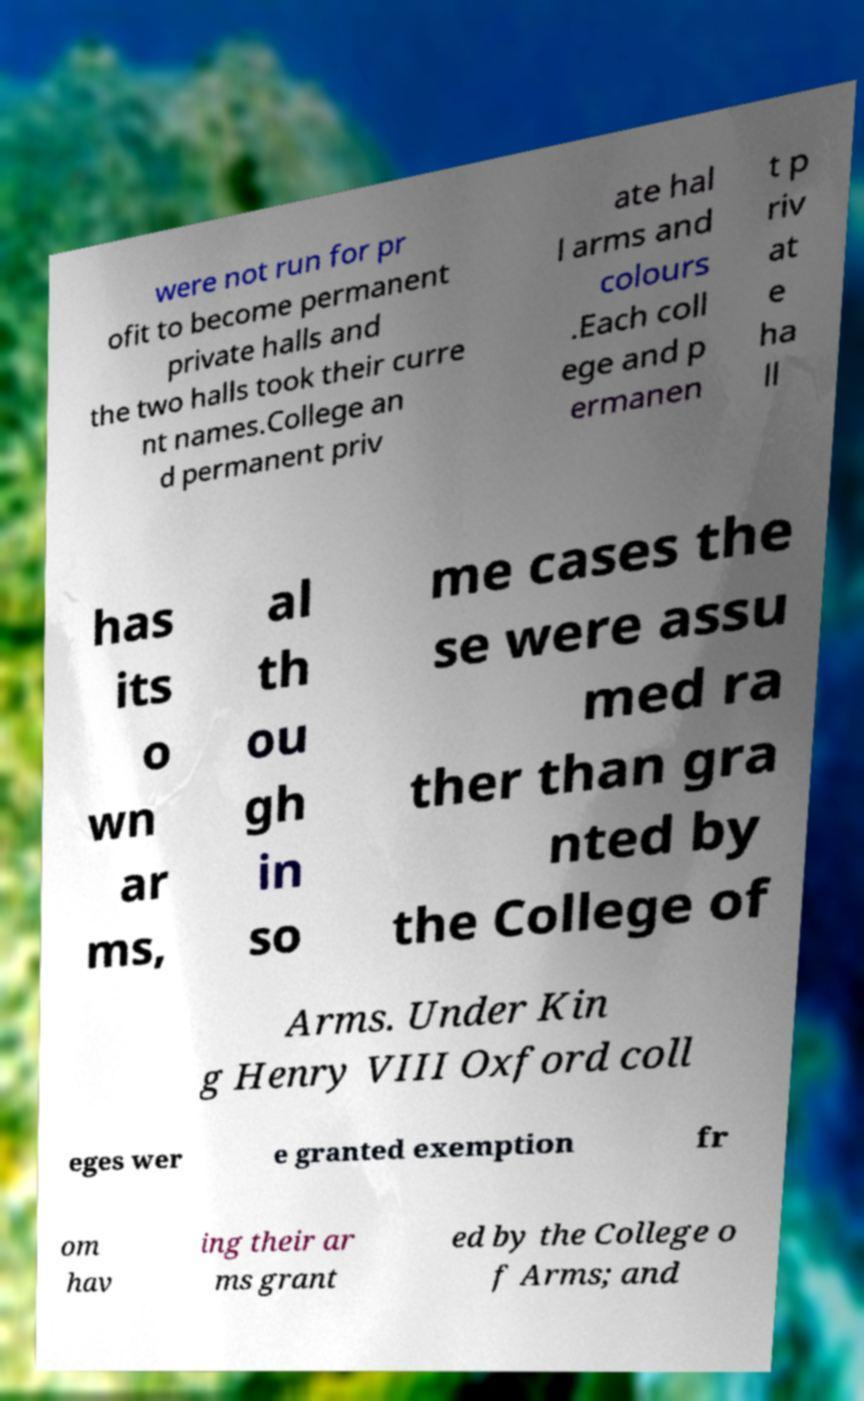Could you assist in decoding the text presented in this image and type it out clearly? were not run for pr ofit to become permanent private halls and the two halls took their curre nt names.College an d permanent priv ate hal l arms and colours .Each coll ege and p ermanen t p riv at e ha ll has its o wn ar ms, al th ou gh in so me cases the se were assu med ra ther than gra nted by the College of Arms. Under Kin g Henry VIII Oxford coll eges wer e granted exemption fr om hav ing their ar ms grant ed by the College o f Arms; and 